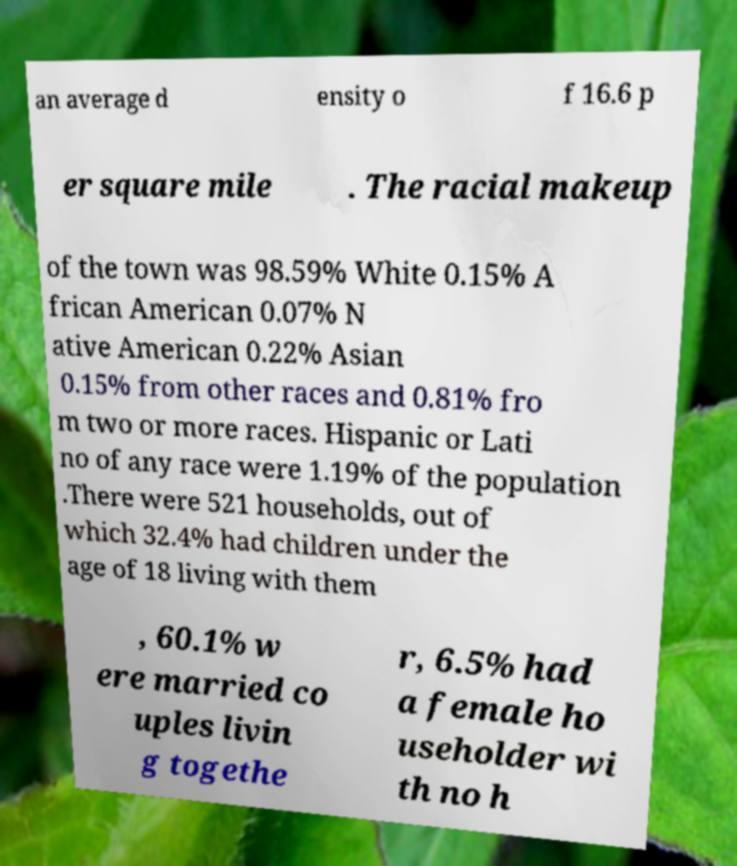Could you extract and type out the text from this image? an average d ensity o f 16.6 p er square mile . The racial makeup of the town was 98.59% White 0.15% A frican American 0.07% N ative American 0.22% Asian 0.15% from other races and 0.81% fro m two or more races. Hispanic or Lati no of any race were 1.19% of the population .There were 521 households, out of which 32.4% had children under the age of 18 living with them , 60.1% w ere married co uples livin g togethe r, 6.5% had a female ho useholder wi th no h 